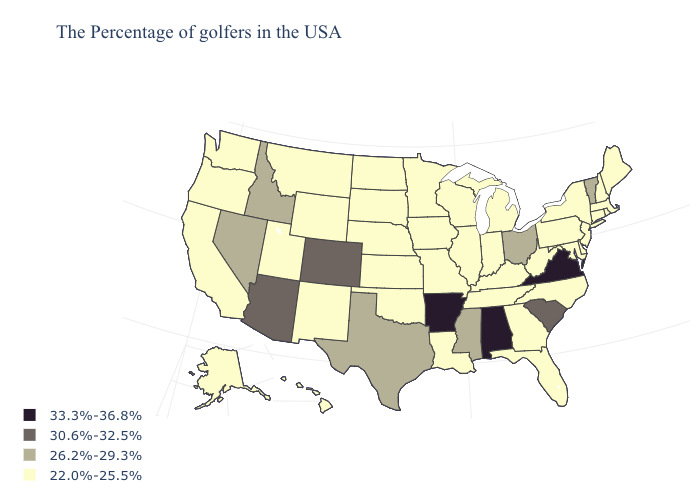Does Wyoming have a lower value than Ohio?
Give a very brief answer. Yes. Name the states that have a value in the range 33.3%-36.8%?
Write a very short answer. Virginia, Alabama, Arkansas. Does Arizona have the lowest value in the West?
Short answer required. No. Name the states that have a value in the range 30.6%-32.5%?
Concise answer only. South Carolina, Colorado, Arizona. Which states hav the highest value in the Northeast?
Give a very brief answer. Vermont. What is the lowest value in the West?
Give a very brief answer. 22.0%-25.5%. What is the lowest value in the Northeast?
Concise answer only. 22.0%-25.5%. Does the first symbol in the legend represent the smallest category?
Give a very brief answer. No. Name the states that have a value in the range 22.0%-25.5%?
Concise answer only. Maine, Massachusetts, Rhode Island, New Hampshire, Connecticut, New York, New Jersey, Delaware, Maryland, Pennsylvania, North Carolina, West Virginia, Florida, Georgia, Michigan, Kentucky, Indiana, Tennessee, Wisconsin, Illinois, Louisiana, Missouri, Minnesota, Iowa, Kansas, Nebraska, Oklahoma, South Dakota, North Dakota, Wyoming, New Mexico, Utah, Montana, California, Washington, Oregon, Alaska, Hawaii. Does Oklahoma have the same value as Colorado?
Short answer required. No. Name the states that have a value in the range 26.2%-29.3%?
Answer briefly. Vermont, Ohio, Mississippi, Texas, Idaho, Nevada. What is the value of Texas?
Short answer required. 26.2%-29.3%. Name the states that have a value in the range 22.0%-25.5%?
Give a very brief answer. Maine, Massachusetts, Rhode Island, New Hampshire, Connecticut, New York, New Jersey, Delaware, Maryland, Pennsylvania, North Carolina, West Virginia, Florida, Georgia, Michigan, Kentucky, Indiana, Tennessee, Wisconsin, Illinois, Louisiana, Missouri, Minnesota, Iowa, Kansas, Nebraska, Oklahoma, South Dakota, North Dakota, Wyoming, New Mexico, Utah, Montana, California, Washington, Oregon, Alaska, Hawaii. What is the value of South Carolina?
Quick response, please. 30.6%-32.5%. Name the states that have a value in the range 33.3%-36.8%?
Give a very brief answer. Virginia, Alabama, Arkansas. 